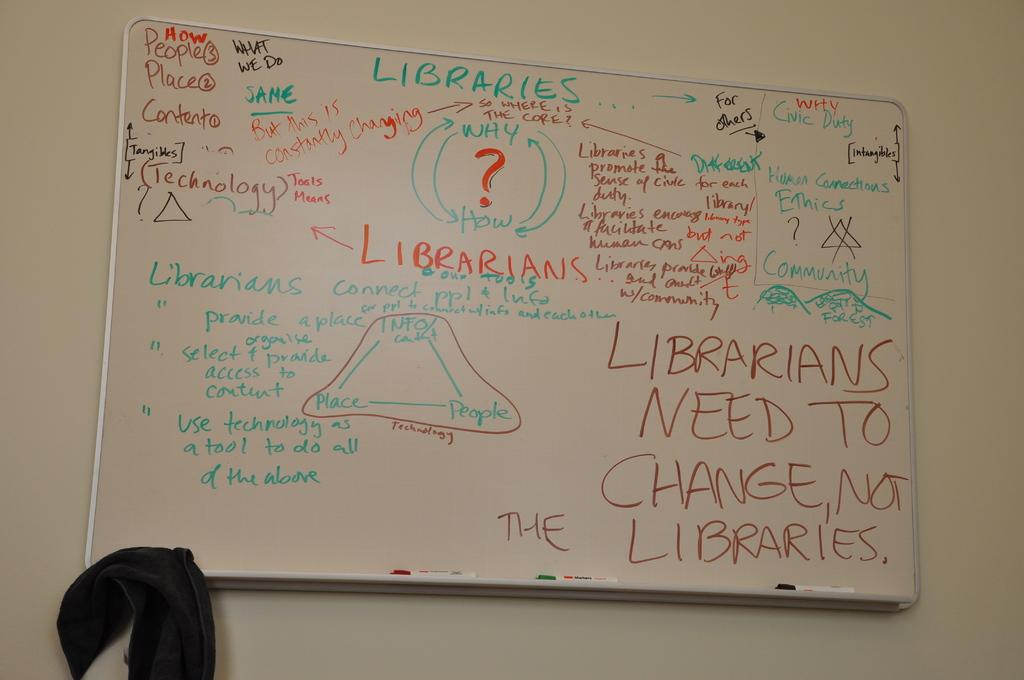<image>
Create a compact narrative representing the image presented. A sign claiming that the librarians need to change 